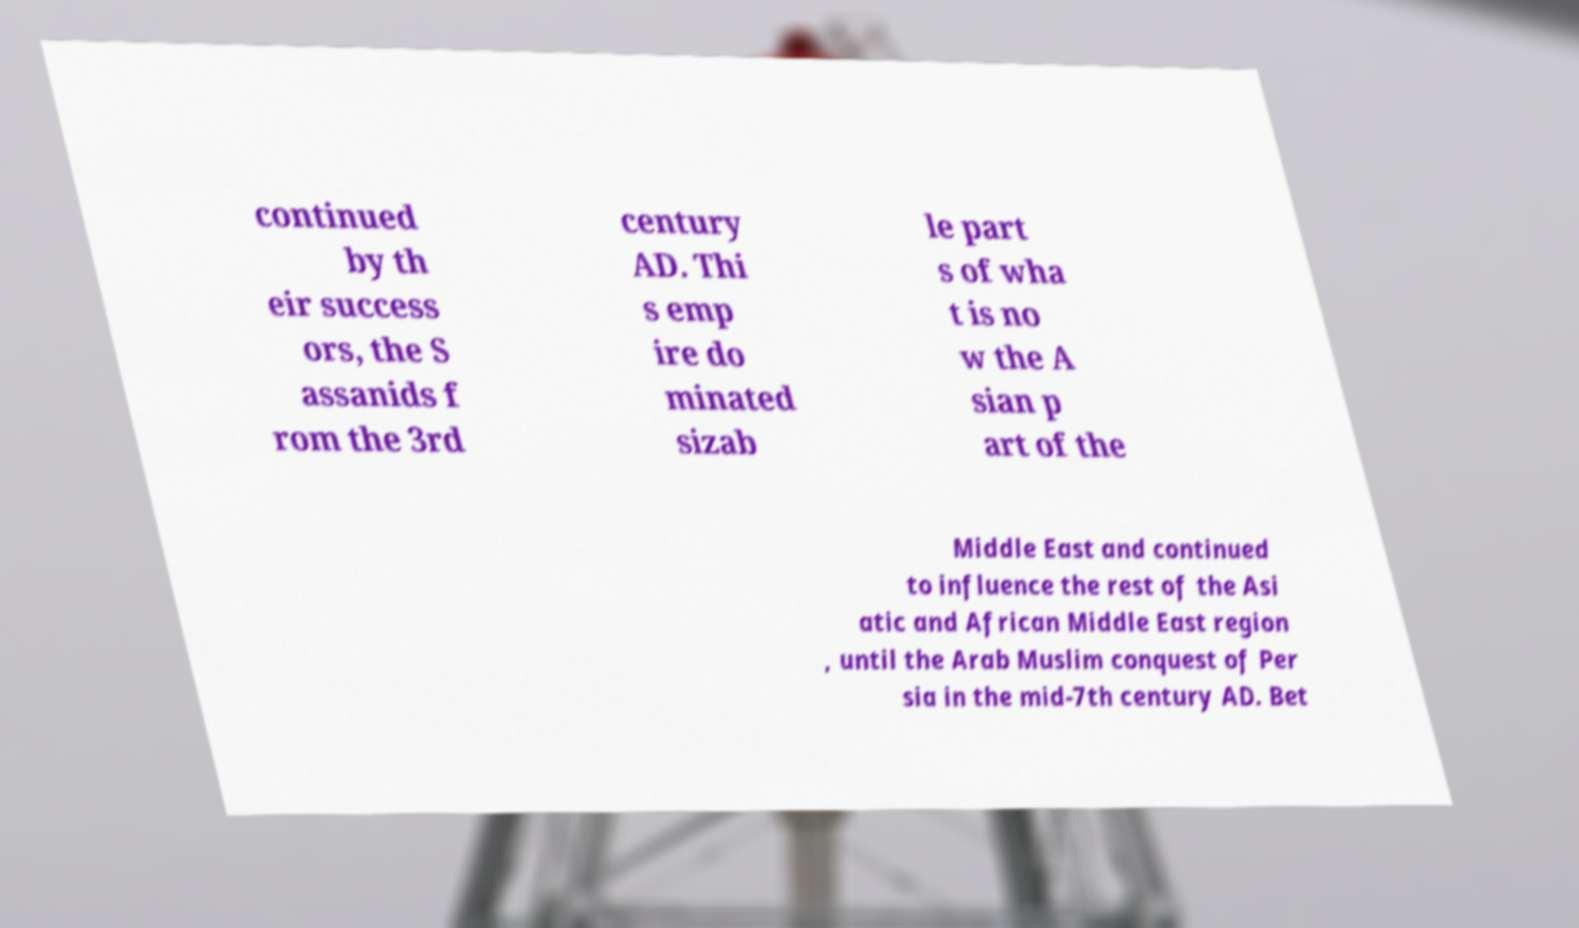I need the written content from this picture converted into text. Can you do that? continued by th eir success ors, the S assanids f rom the 3rd century AD. Thi s emp ire do minated sizab le part s of wha t is no w the A sian p art of the Middle East and continued to influence the rest of the Asi atic and African Middle East region , until the Arab Muslim conquest of Per sia in the mid-7th century AD. Bet 